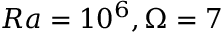<formula> <loc_0><loc_0><loc_500><loc_500>R a = 1 0 ^ { 6 } , \Omega = 7</formula> 